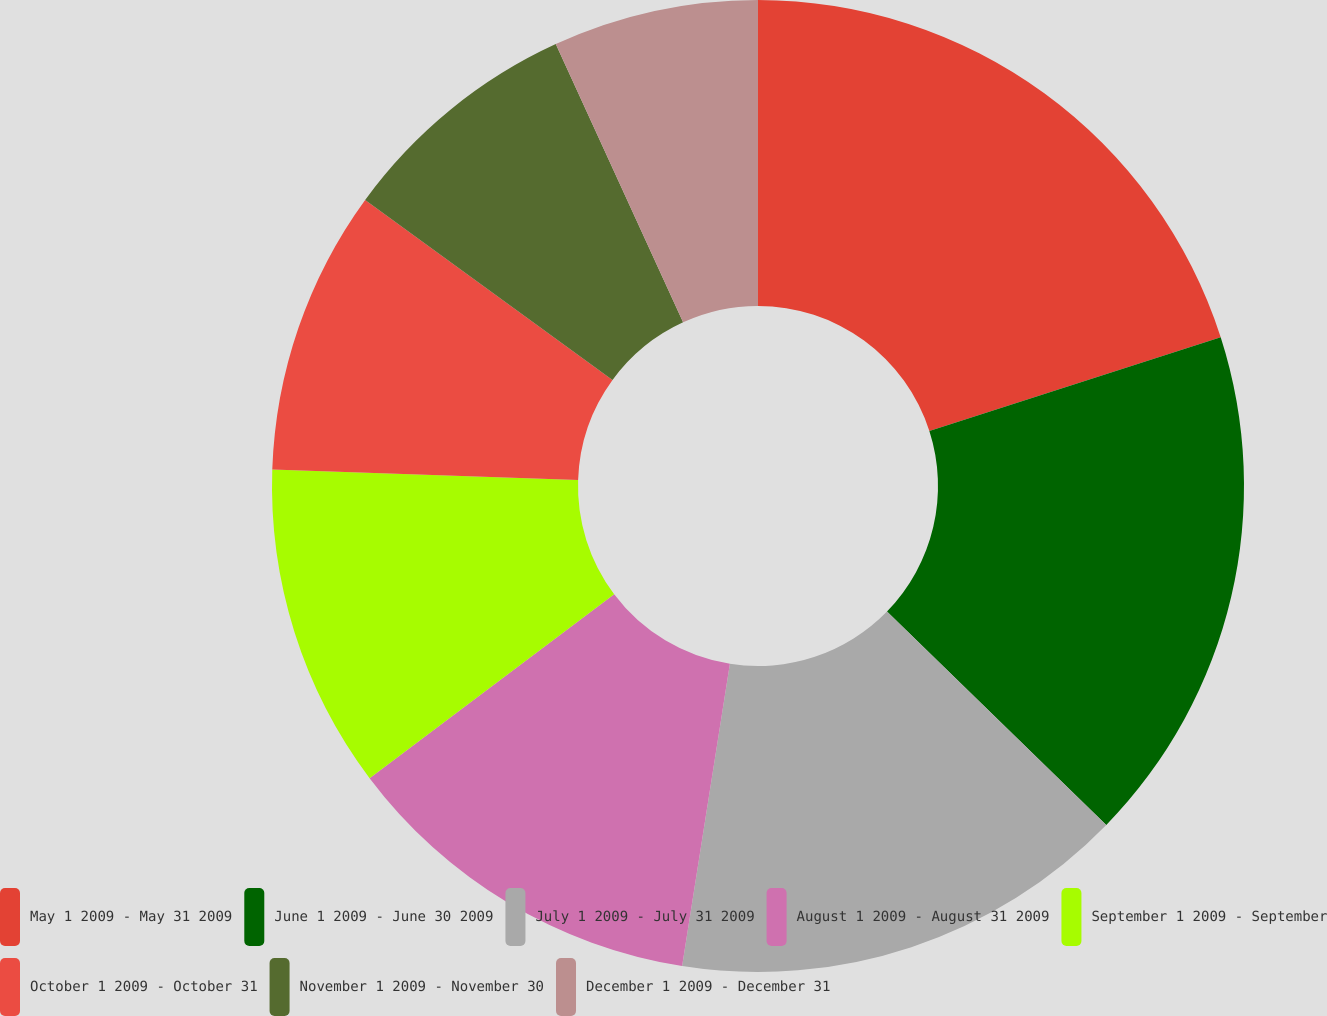<chart> <loc_0><loc_0><loc_500><loc_500><pie_chart><fcel>May 1 2009 - May 31 2009<fcel>June 1 2009 - June 30 2009<fcel>July 1 2009 - July 31 2009<fcel>August 1 2009 - August 31 2009<fcel>September 1 2009 - September<fcel>October 1 2009 - October 31<fcel>November 1 2009 - November 30<fcel>December 1 2009 - December 31<nl><fcel>20.05%<fcel>17.23%<fcel>15.21%<fcel>12.24%<fcel>10.8%<fcel>9.48%<fcel>8.15%<fcel>6.83%<nl></chart> 